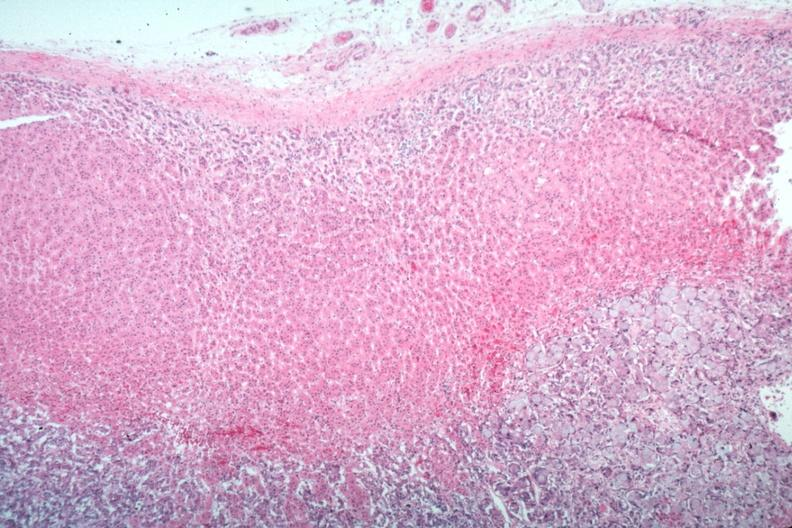what is present?
Answer the question using a single word or phrase. Metastatic carcinoma 